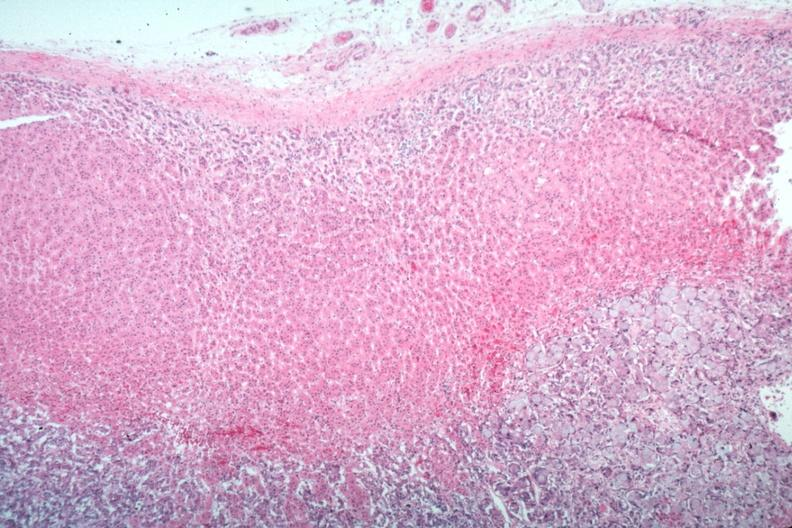what is present?
Answer the question using a single word or phrase. Metastatic carcinoma 